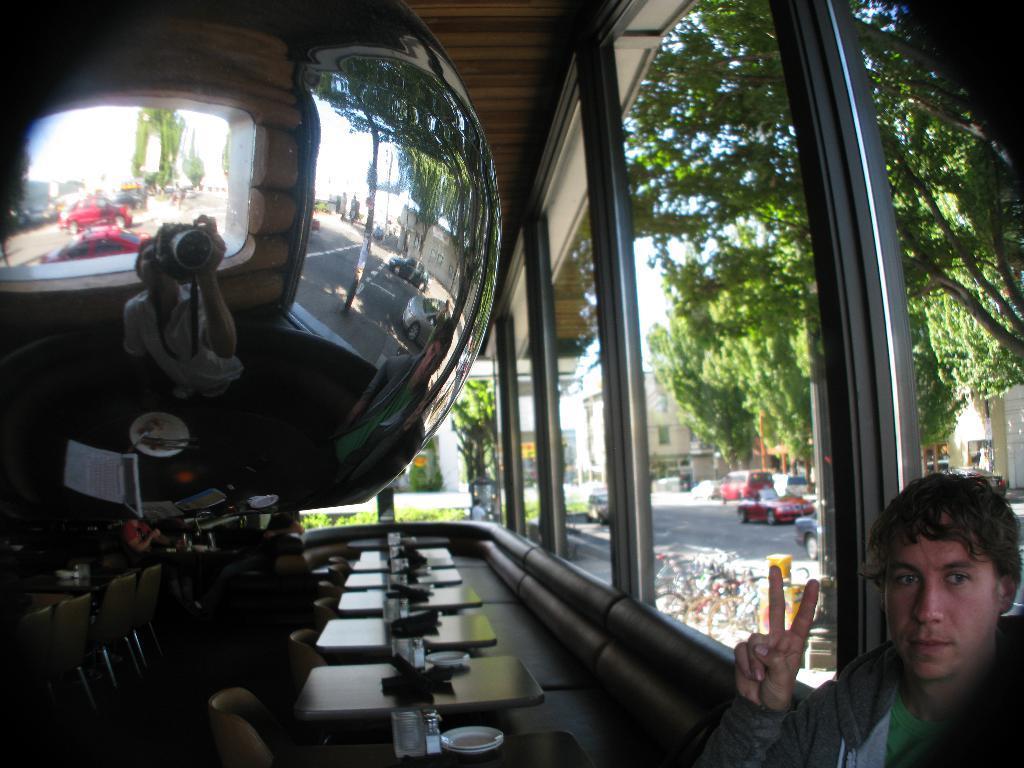Please provide a concise description of this image. This image is clicked inside a room. There are tables, chairs and couches in the room. On the tables there are plates, glasses and bottles. In the bottom right there is a man sitting. Behind him there are glass walls. Outside the glass walls there is a road. There are vehicles moving on the road. There are bicycles parked on the walkway. Beside the road there are buildings and trees. In the top left there is an object. In the reflection of the object we can see a person holding a camera. 